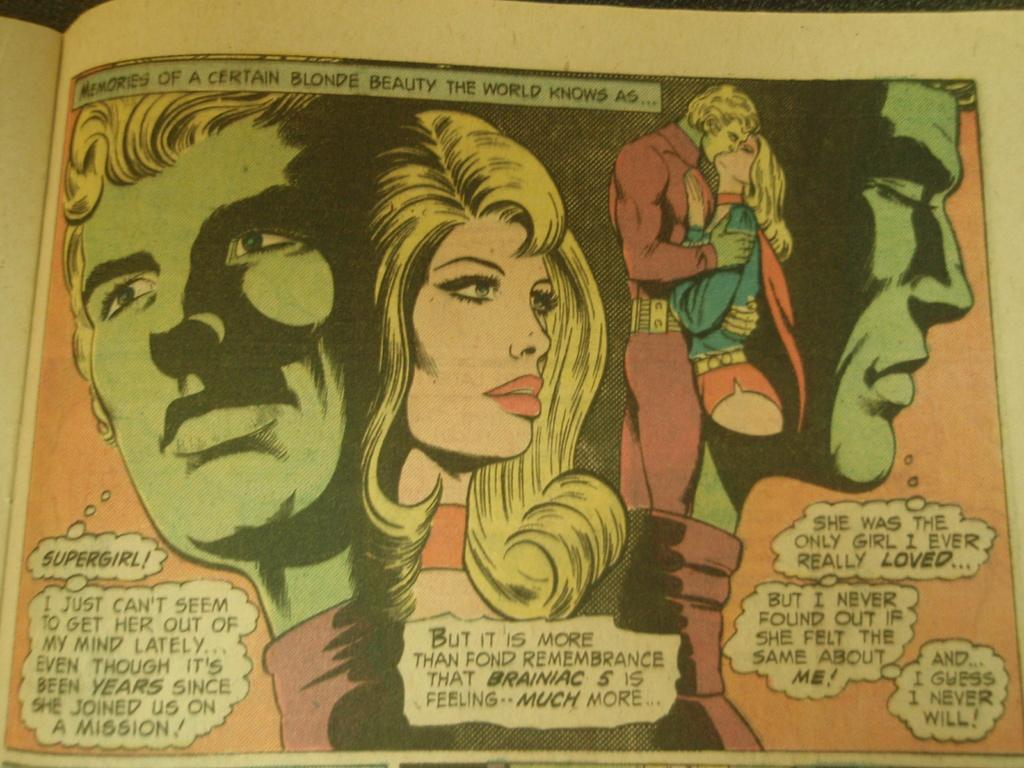<image>
Give a short and clear explanation of the subsequent image. A comic book shows one of the characters saying supergirl. 